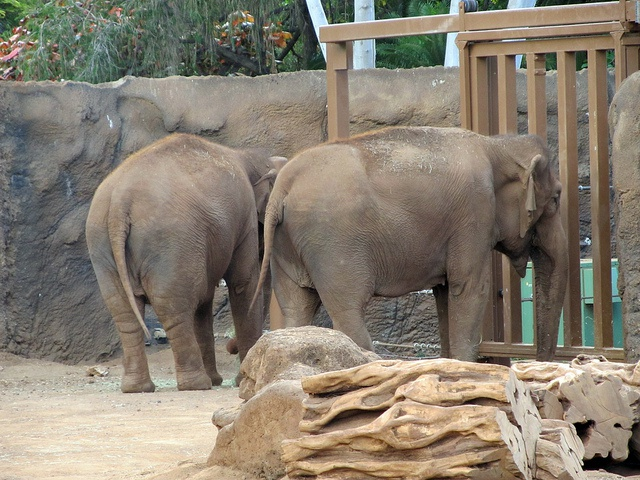Describe the objects in this image and their specific colors. I can see elephant in darkgreen, gray, and darkgray tones and elephant in darkgreen, gray, and darkgray tones in this image. 